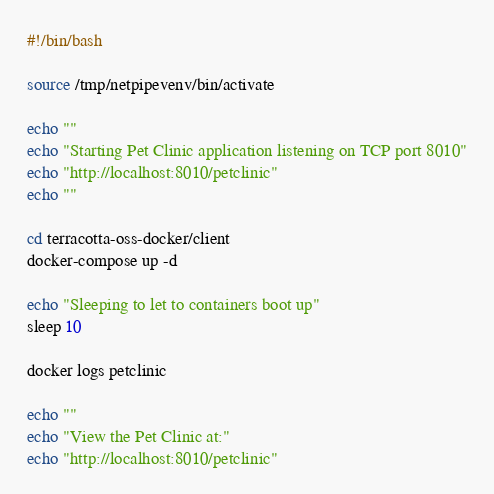<code> <loc_0><loc_0><loc_500><loc_500><_Bash_>#!/bin/bash

source /tmp/netpipevenv/bin/activate

echo ""
echo "Starting Pet Clinic application listening on TCP port 8010"
echo "http://localhost:8010/petclinic"
echo ""

cd terracotta-oss-docker/client
docker-compose up -d

echo "Sleeping to let to containers boot up"
sleep 10

docker logs petclinic

echo ""
echo "View the Pet Clinic at:"
echo "http://localhost:8010/petclinic"
</code> 